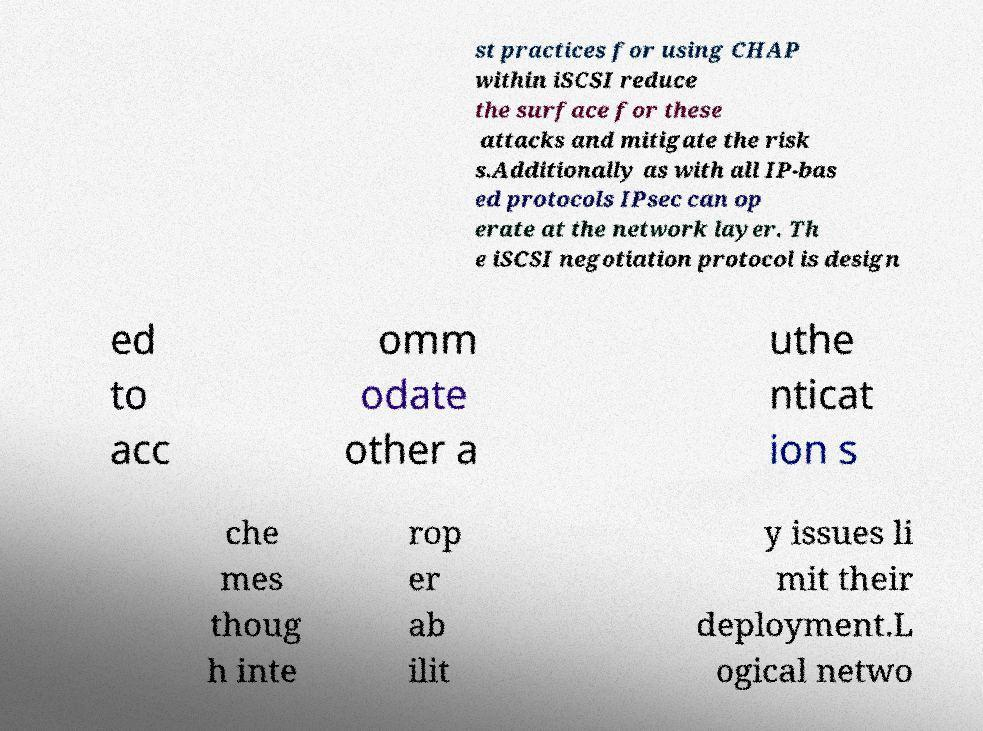What messages or text are displayed in this image? I need them in a readable, typed format. st practices for using CHAP within iSCSI reduce the surface for these attacks and mitigate the risk s.Additionally as with all IP-bas ed protocols IPsec can op erate at the network layer. Th e iSCSI negotiation protocol is design ed to acc omm odate other a uthe nticat ion s che mes thoug h inte rop er ab ilit y issues li mit their deployment.L ogical netwo 